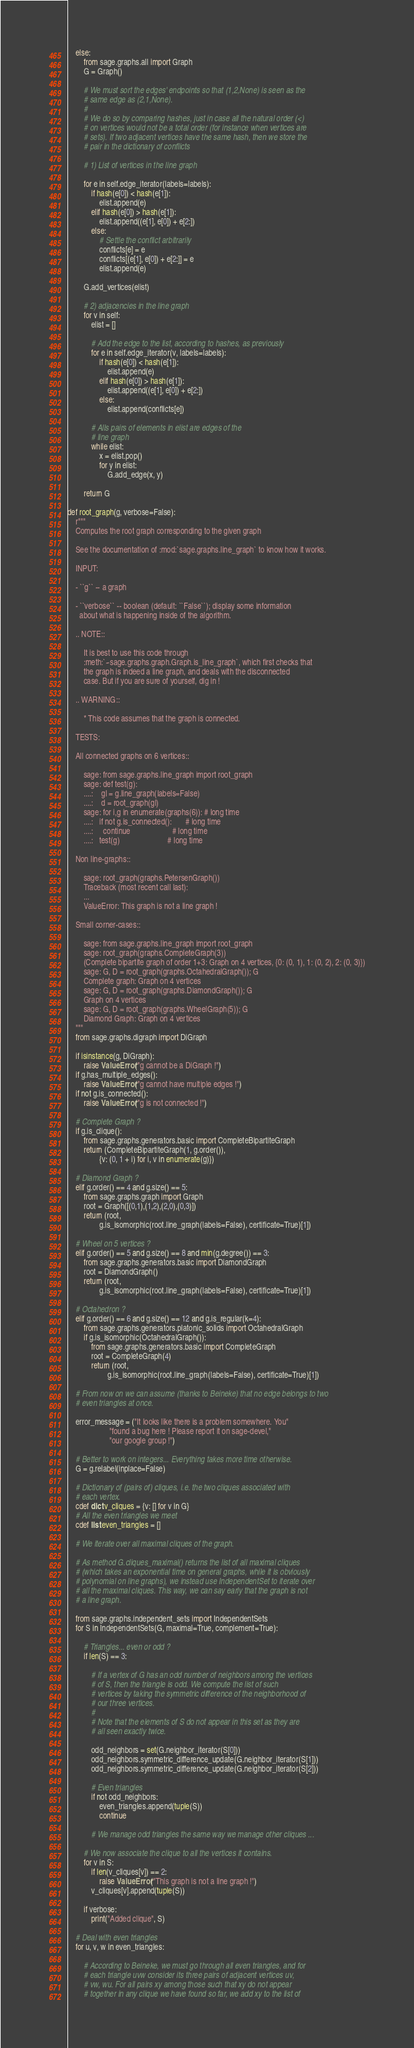<code> <loc_0><loc_0><loc_500><loc_500><_Cython_>    else:
        from sage.graphs.all import Graph
        G = Graph()

        # We must sort the edges' endpoints so that (1,2,None) is seen as the
        # same edge as (2,1,None).
        #
        # We do so by comparing hashes, just in case all the natural order (<)
        # on vertices would not be a total order (for instance when vertices are
        # sets). If two adjacent vertices have the same hash, then we store the
        # pair in the dictionary of conflicts

        # 1) List of vertices in the line graph

        for e in self.edge_iterator(labels=labels):
            if hash(e[0]) < hash(e[1]):
                elist.append(e)
            elif hash(e[0]) > hash(e[1]):
                elist.append((e[1], e[0]) + e[2:])
            else:
                # Settle the conflict arbitrarily
                conflicts[e] = e
                conflicts[(e[1], e[0]) + e[2:]] = e
                elist.append(e)

        G.add_vertices(elist)

        # 2) adjacencies in the line graph
        for v in self:
            elist = []

            # Add the edge to the list, according to hashes, as previously
            for e in self.edge_iterator(v, labels=labels):
                if hash(e[0]) < hash(e[1]):
                    elist.append(e)
                elif hash(e[0]) > hash(e[1]):
                    elist.append((e[1], e[0]) + e[2:])
                else:
                    elist.append(conflicts[e])

            # Alls pairs of elements in elist are edges of the
            # line graph
            while elist:
                x = elist.pop()
                for y in elist:
                    G.add_edge(x, y)

        return G

def root_graph(g, verbose=False):
    r"""
    Computes the root graph corresponding to the given graph

    See the documentation of :mod:`sage.graphs.line_graph` to know how it works.

    INPUT:

    - ``g`` -- a graph

    - ``verbose`` -- boolean (default: ``False``); display some information
      about what is happening inside of the algorithm.

    .. NOTE::

        It is best to use this code through
        :meth:`~sage.graphs.graph.Graph.is_line_graph`, which first checks that
        the graph is indeed a line graph, and deals with the disconnected
        case. But if you are sure of yourself, dig in !

    .. WARNING::

        * This code assumes that the graph is connected.

    TESTS:

    All connected graphs on 6 vertices::

        sage: from sage.graphs.line_graph import root_graph
        sage: def test(g):
        ....:    gl = g.line_graph(labels=False)
        ....:    d = root_graph(gl)
        sage: for i,g in enumerate(graphs(6)): # long time
        ....:   if not g.is_connected():       # long time
        ....:     continue                     # long time
        ....:   test(g)                        # long time

    Non line-graphs::

        sage: root_graph(graphs.PetersenGraph())
        Traceback (most recent call last):
        ...
        ValueError: This graph is not a line graph !

    Small corner-cases::

        sage: from sage.graphs.line_graph import root_graph
        sage: root_graph(graphs.CompleteGraph(3))
        (Complete bipartite graph of order 1+3: Graph on 4 vertices, {0: (0, 1), 1: (0, 2), 2: (0, 3)})
        sage: G, D = root_graph(graphs.OctahedralGraph()); G
        Complete graph: Graph on 4 vertices
        sage: G, D = root_graph(graphs.DiamondGraph()); G
        Graph on 4 vertices
        sage: G, D = root_graph(graphs.WheelGraph(5)); G
        Diamond Graph: Graph on 4 vertices
    """
    from sage.graphs.digraph import DiGraph

    if isinstance(g, DiGraph):
        raise ValueError("g cannot be a DiGraph !")
    if g.has_multiple_edges():
        raise ValueError("g cannot have multiple edges !")
    if not g.is_connected():
        raise ValueError("g is not connected !")

    # Complete Graph ?
    if g.is_clique():
        from sage.graphs.generators.basic import CompleteBipartiteGraph
        return (CompleteBipartiteGraph(1, g.order()),
                {v: (0, 1 + i) for i, v in enumerate(g)})

    # Diamond Graph ?
    elif g.order() == 4 and g.size() == 5:
        from sage.graphs.graph import Graph
        root = Graph([(0,1),(1,2),(2,0),(0,3)])
        return (root,
                g.is_isomorphic(root.line_graph(labels=False), certificate=True)[1])

    # Wheel on 5 vertices ?
    elif g.order() == 5 and g.size() == 8 and min(g.degree()) == 3:
        from sage.graphs.generators.basic import DiamondGraph
        root = DiamondGraph()
        return (root,
                g.is_isomorphic(root.line_graph(labels=False), certificate=True)[1])

    # Octahedron ?
    elif g.order() == 6 and g.size() == 12 and g.is_regular(k=4):
        from sage.graphs.generators.platonic_solids import OctahedralGraph
        if g.is_isomorphic(OctahedralGraph()):
            from sage.graphs.generators.basic import CompleteGraph
            root = CompleteGraph(4)
            return (root,
                    g.is_isomorphic(root.line_graph(labels=False), certificate=True)[1])

    # From now on we can assume (thanks to Beineke) that no edge belongs to two
    # even triangles at once.

    error_message = ("It looks like there is a problem somewhere. You"
                     "found a bug here ! Please report it on sage-devel,"
                     "our google group !")

    # Better to work on integers... Everything takes more time otherwise.
    G = g.relabel(inplace=False)

    # Dictionary of (pairs of) cliques, i.e. the two cliques associated with
    # each vertex.
    cdef dict v_cliques = {v: [] for v in G}
    # All the even triangles we meet
    cdef list even_triangles = []

    # We iterate over all maximal cliques of the graph.

    # As method G.cliques_maximal() returns the list of all maximal cliques
    # (which takes an exponential time on general graphs, while it is obviously
    # polynomial on line graphs), we instead use IndependentSet to iterate over
    # all the maximal cliques. This way, we can say early that the graph is not
    # a line graph.

    from sage.graphs.independent_sets import IndependentSets
    for S in IndependentSets(G, maximal=True, complement=True):

        # Triangles... even or odd ?
        if len(S) == 3:

            # If a vertex of G has an odd number of neighbors among the vertices
            # of S, then the triangle is odd. We compute the list of such
            # vertices by taking the symmetric difference of the neighborhood of
            # our three vertices.
            #
            # Note that the elements of S do not appear in this set as they are
            # all seen exactly twice.

            odd_neighbors = set(G.neighbor_iterator(S[0]))
            odd_neighbors.symmetric_difference_update(G.neighbor_iterator(S[1]))
            odd_neighbors.symmetric_difference_update(G.neighbor_iterator(S[2]))

            # Even triangles
            if not odd_neighbors:
                even_triangles.append(tuple(S))
                continue

            # We manage odd triangles the same way we manage other cliques ...

        # We now associate the clique to all the vertices it contains.
        for v in S:
            if len(v_cliques[v]) == 2:
                raise ValueError("This graph is not a line graph !")
            v_cliques[v].append(tuple(S))

        if verbose:
            print("Added clique", S)

    # Deal with even triangles
    for u, v, w in even_triangles:

        # According to Beineke, we must go through all even triangles, and for
        # each triangle uvw consider its three pairs of adjacent vertices uv,
        # vw, wu. For all pairs xy among those such that xy do not appear
        # together in any clique we have found so far, we add xy to the list of</code> 